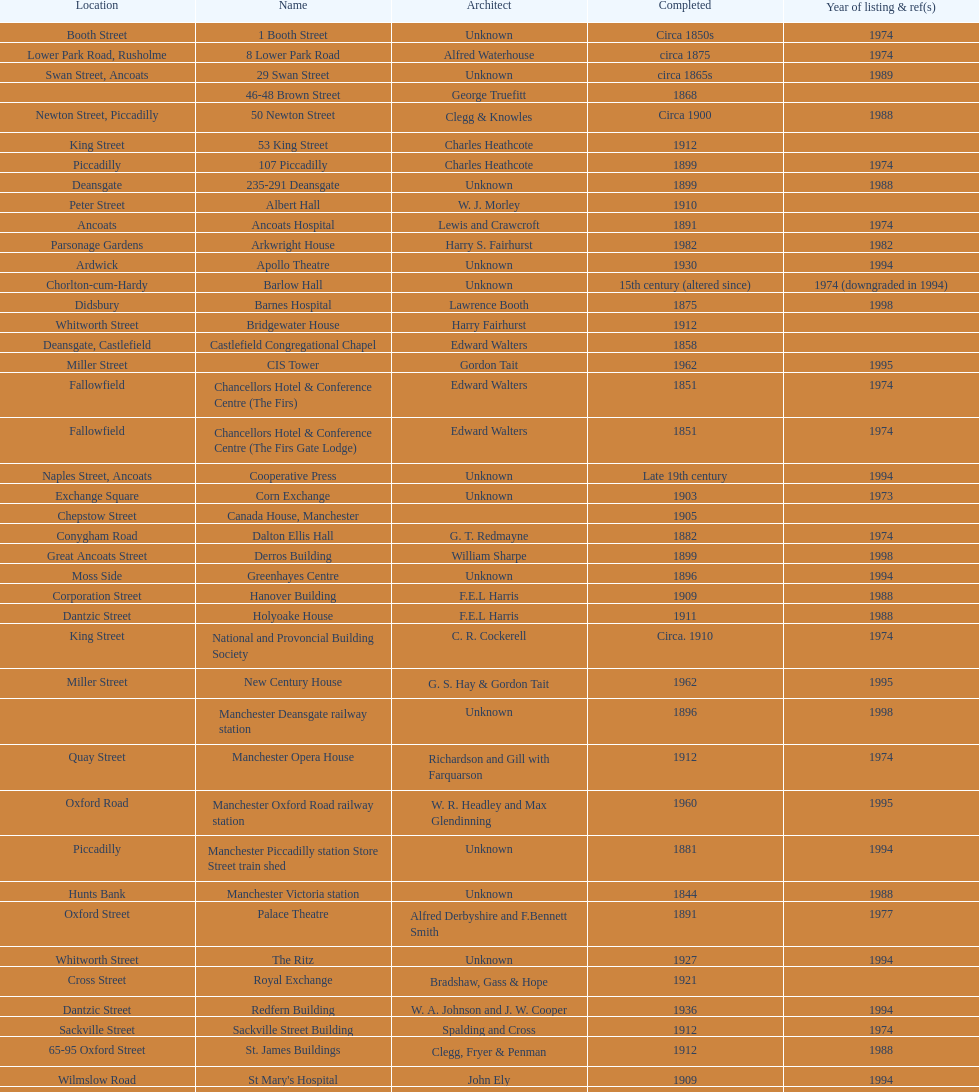How many buildings had alfred waterhouse as their architect? 3. 